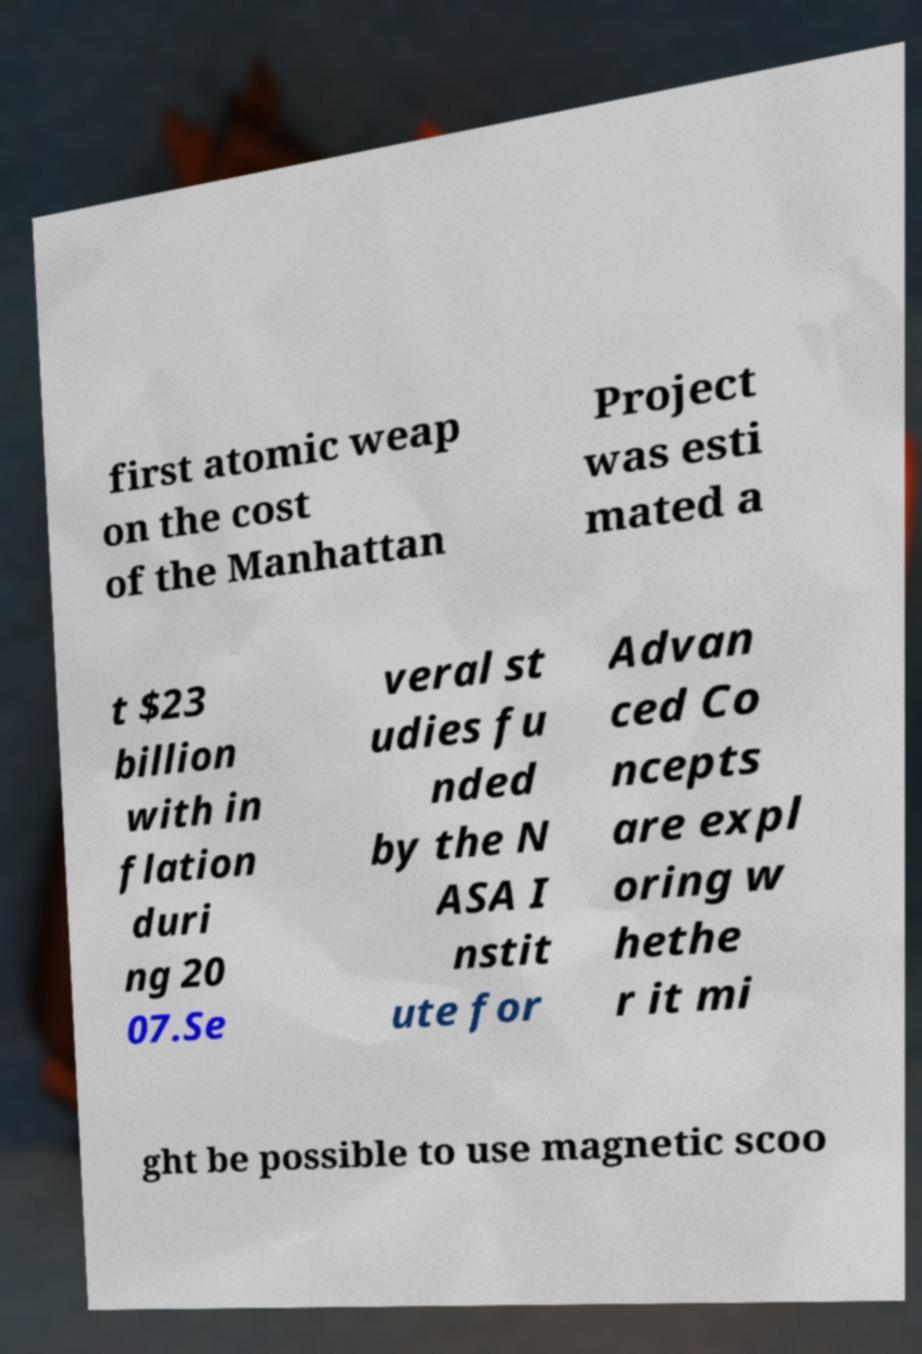There's text embedded in this image that I need extracted. Can you transcribe it verbatim? first atomic weap on the cost of the Manhattan Project was esti mated a t $23 billion with in flation duri ng 20 07.Se veral st udies fu nded by the N ASA I nstit ute for Advan ced Co ncepts are expl oring w hethe r it mi ght be possible to use magnetic scoo 